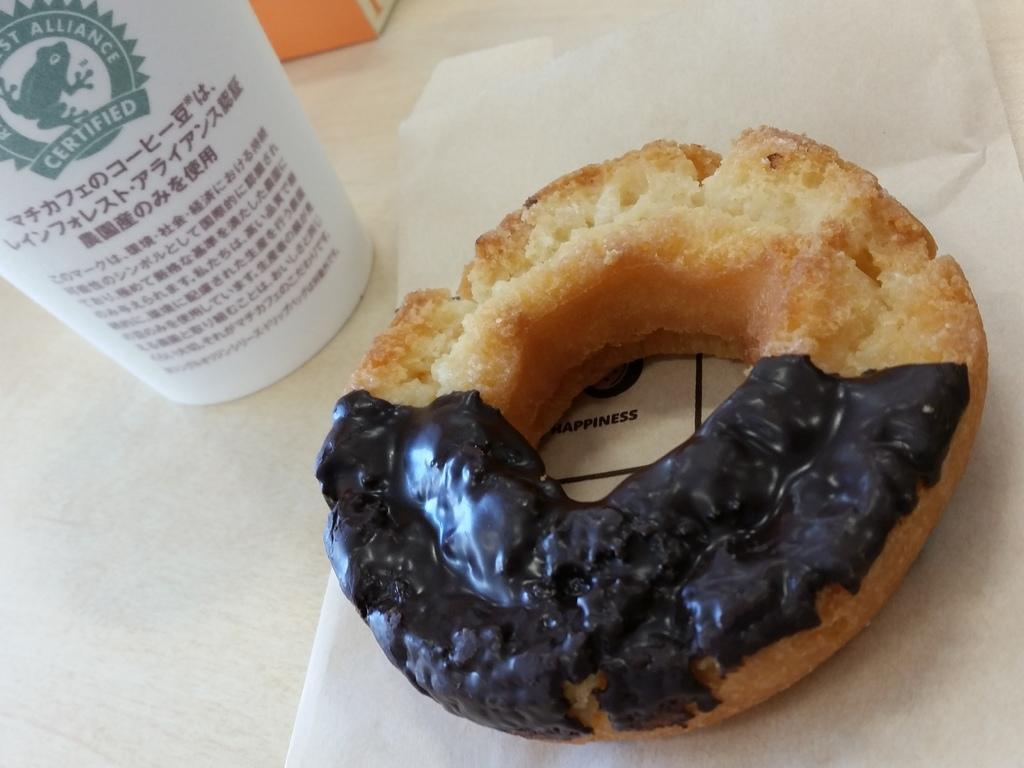What is the food item on paper in the image? The specific food item cannot be determined from the provided facts. What does the text on the cup say? The text on the cup cannot be determined from the provided facts. What is the object on the table in the image? The specific object on the table cannot be determined from the provided facts. Is there a spy hiding behind the cup in the image? There is no mention of a spy or any hidden objects in the provided facts, so it cannot be determined from the image. 